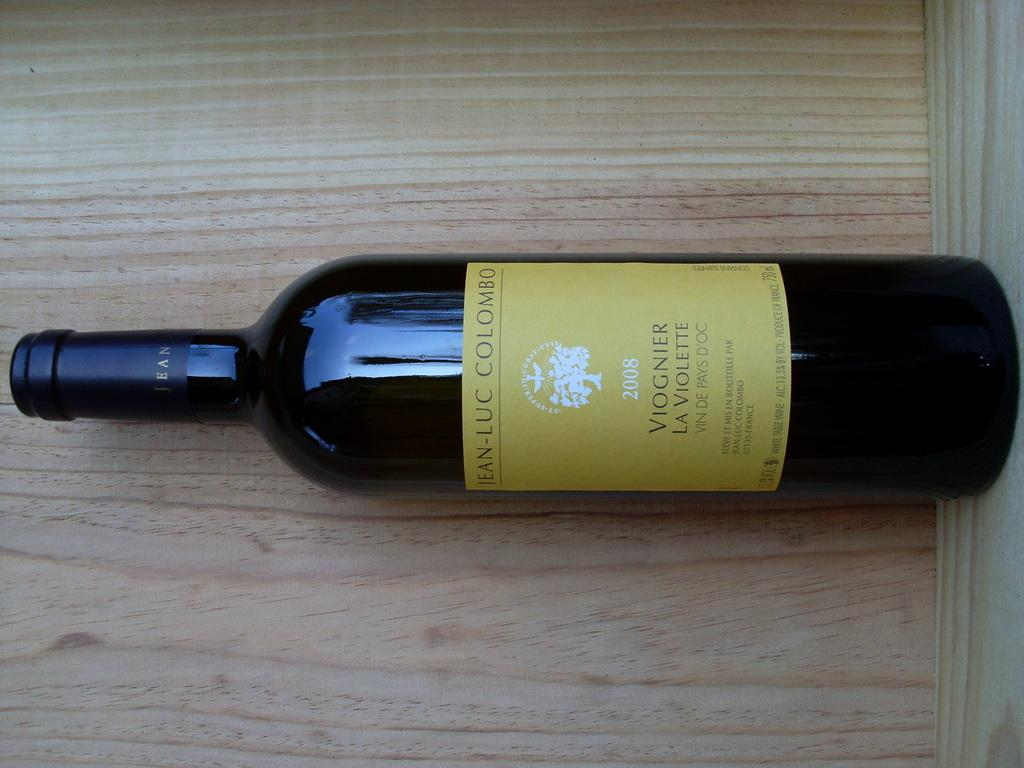<image>
Summarize the visual content of the image. A bottle of Viognier La Violette from 2008 lies on the board. 